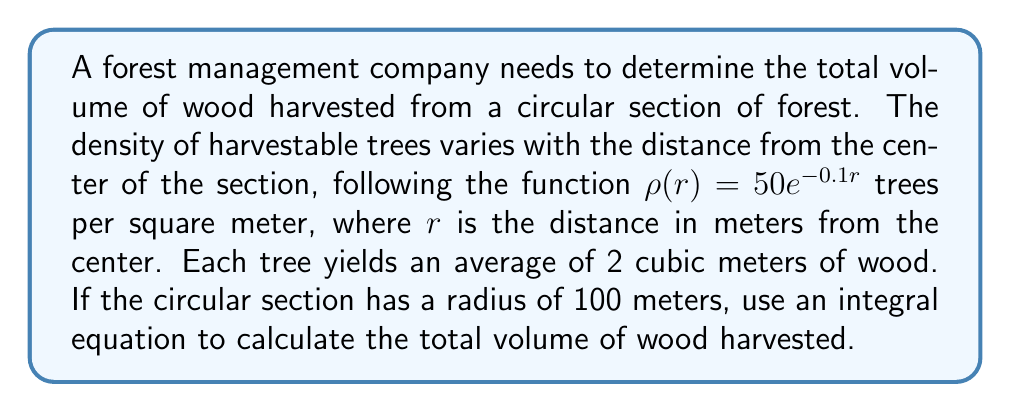Can you solve this math problem? To solve this problem, we'll follow these steps:

1) The area of a circular ring at distance $r$ from the center with width $dr$ is $2\pi r dr$.

2) The number of trees in this ring is $\rho(r) \cdot 2\pi r dr = 50e^{-0.1r} \cdot 2\pi r dr$.

3) Each tree yields 2 cubic meters of wood, so the volume of wood from this ring is:
   $2 \cdot 50e^{-0.1r} \cdot 2\pi r dr = 200\pi r e^{-0.1r} dr$

4) To get the total volume, we integrate this from $r=0$ to $r=100$:

   $$V = \int_0^{100} 200\pi r e^{-0.1r} dr$$

5) To solve this integral, we use integration by parts:
   Let $u = r$ and $dv = e^{-0.1r} dr$
   Then $du = dr$ and $v = -10e^{-0.1r}$

   $$V = 200\pi \left[-10re^{-0.1r}\right]_0^{100} + 200\pi \int_0^{100} 10e^{-0.1r} dr$$

6) Evaluating:
   $$V = 200\pi \left[-1000e^{-10} + 0\right] + 200\pi \left[-100e^{-0.1r}\right]_0^{100}$$
   $$V = 200\pi \left[-1000e^{-10} - 100e^{-10} + 100\right]$$
   $$V = 20000\pi - 220000\pi e^{-10}$$

7) Using a calculator for the final value:
   $$V \approx 62831.85 \text{ cubic meters}$$
Answer: $62831.85 \text{ m}^3$ 